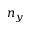<formula> <loc_0><loc_0><loc_500><loc_500>n _ { y }</formula> 